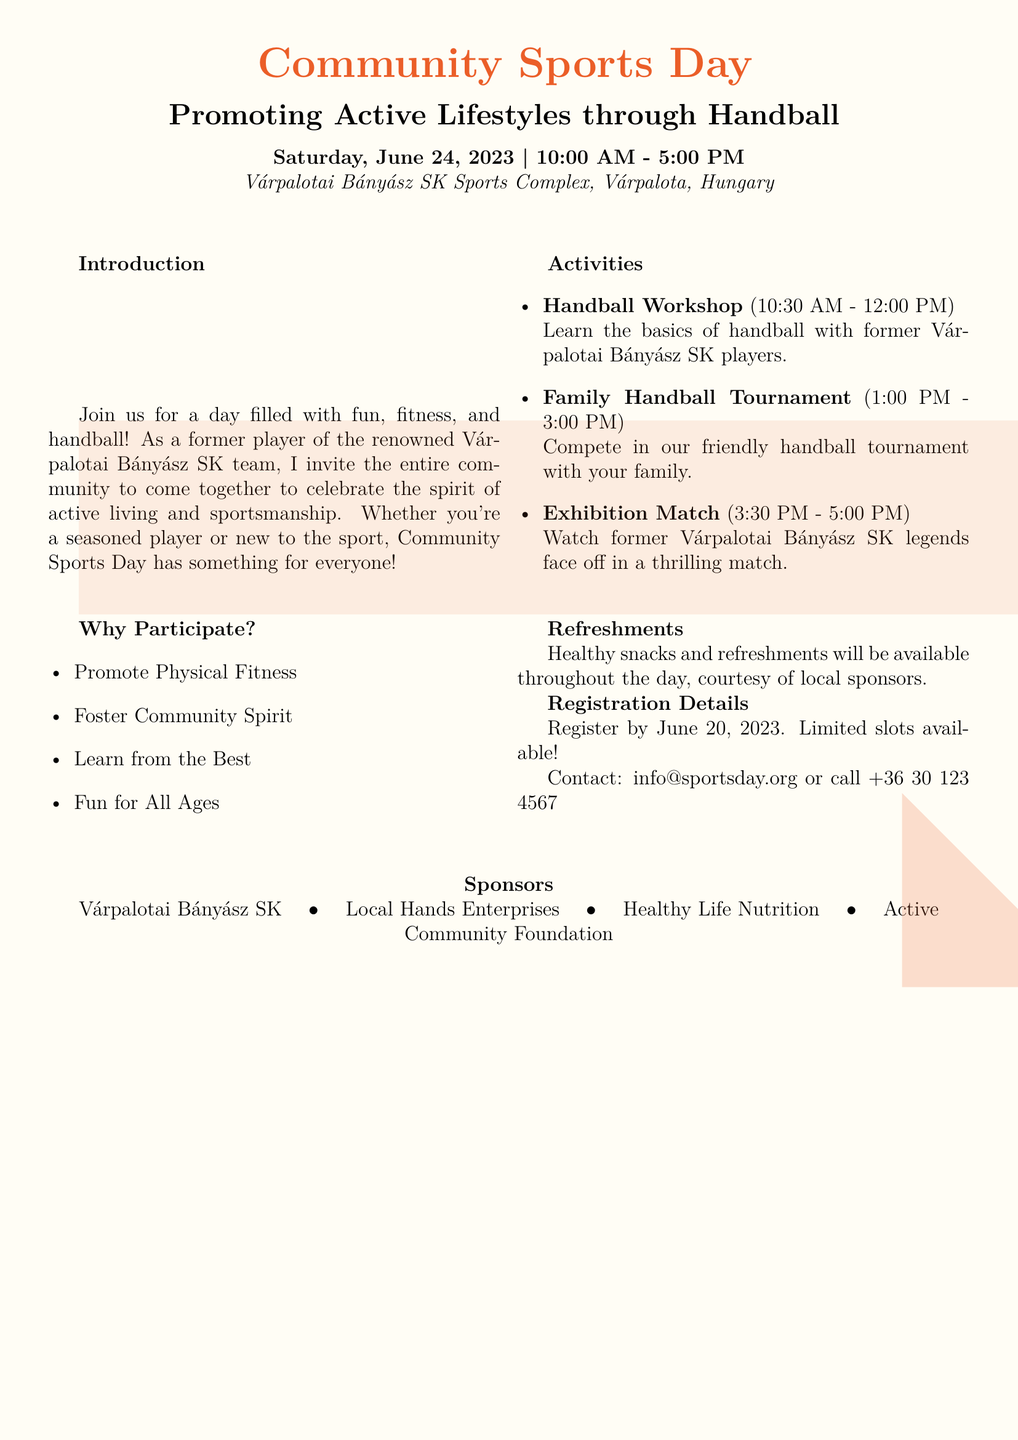What is the date of the Community Sports Day? The date is specified in the document as June 24, 2023.
Answer: June 24, 2023 What time does the event start? The starting time is mentioned in the document as 10:00 AM.
Answer: 10:00 AM What is one of the activities scheduled for the morning? The document mentions a Handball Workshop scheduled from 10:30 AM to 12:00 PM.
Answer: Handball Workshop Who is invited to join the activities? The document invites the entire community to participate in the event.
Answer: Entire community What is the purpose of the Community Sports Day? The main aim is to promote active lifestyles and sportsmanship through handball.
Answer: Promote active lifestyles By when do participants need to register? The document states that registration should be completed by June 20, 2023.
Answer: June 20, 2023 What type of refreshments will be available? The document indicates that healthy snacks and refreshments will be provided.
Answer: Healthy snacks Who can learn during the Handball Workshop? The workshop is designed for both seasoned players and newcomers to the sport.
Answer: Everyone What is one benefit of participating in the event? One benefit listed is the opportunity to foster community spirit.
Answer: Foster community spirit 